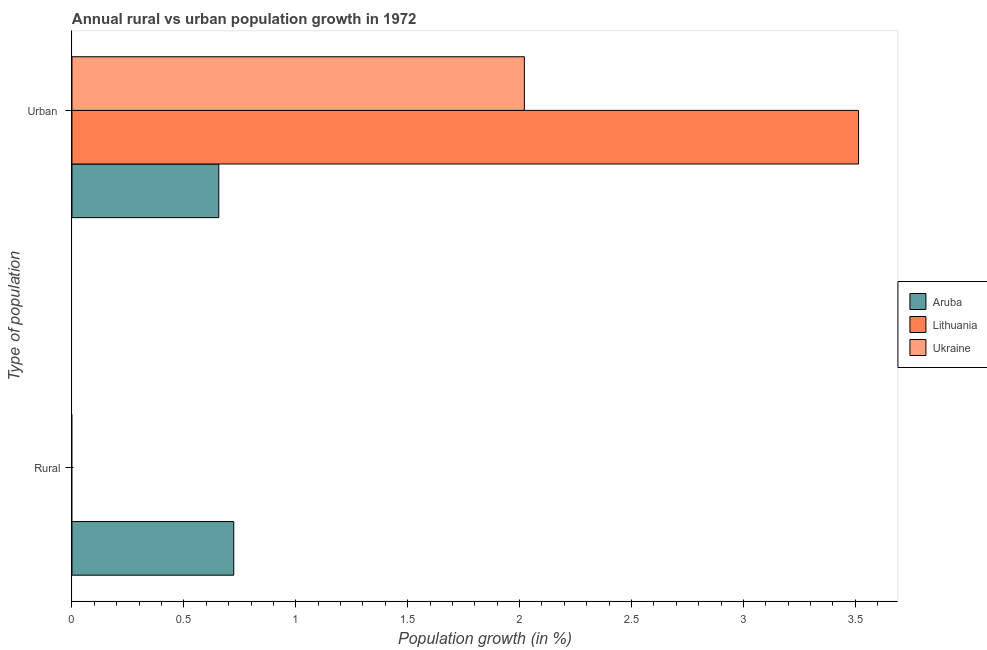Are the number of bars per tick equal to the number of legend labels?
Your response must be concise. No. Are the number of bars on each tick of the Y-axis equal?
Offer a terse response. No. How many bars are there on the 1st tick from the top?
Ensure brevity in your answer.  3. What is the label of the 2nd group of bars from the top?
Give a very brief answer. Rural. What is the urban population growth in Ukraine?
Provide a succinct answer. 2.02. Across all countries, what is the maximum urban population growth?
Ensure brevity in your answer.  3.51. Across all countries, what is the minimum urban population growth?
Offer a very short reply. 0.66. In which country was the urban population growth maximum?
Your answer should be compact. Lithuania. What is the total rural population growth in the graph?
Your answer should be compact. 0.72. What is the difference between the urban population growth in Lithuania and that in Ukraine?
Offer a terse response. 1.49. What is the difference between the urban population growth in Lithuania and the rural population growth in Ukraine?
Your response must be concise. 3.51. What is the average urban population growth per country?
Your response must be concise. 2.06. What is the difference between the rural population growth and urban population growth in Aruba?
Your response must be concise. 0.07. What is the ratio of the urban population growth in Aruba to that in Ukraine?
Give a very brief answer. 0.32. How many bars are there?
Keep it short and to the point. 4. How many countries are there in the graph?
Your answer should be compact. 3. What is the difference between two consecutive major ticks on the X-axis?
Offer a terse response. 0.5. Are the values on the major ticks of X-axis written in scientific E-notation?
Provide a short and direct response. No. Does the graph contain any zero values?
Your answer should be compact. Yes. How many legend labels are there?
Provide a succinct answer. 3. How are the legend labels stacked?
Give a very brief answer. Vertical. What is the title of the graph?
Your response must be concise. Annual rural vs urban population growth in 1972. What is the label or title of the X-axis?
Offer a very short reply. Population growth (in %). What is the label or title of the Y-axis?
Keep it short and to the point. Type of population. What is the Population growth (in %) in Aruba in Rural?
Offer a terse response. 0.72. What is the Population growth (in %) of Ukraine in Rural?
Give a very brief answer. 0. What is the Population growth (in %) in Aruba in Urban ?
Keep it short and to the point. 0.66. What is the Population growth (in %) in Lithuania in Urban ?
Your answer should be very brief. 3.51. What is the Population growth (in %) in Ukraine in Urban ?
Offer a terse response. 2.02. Across all Type of population, what is the maximum Population growth (in %) in Aruba?
Your answer should be very brief. 0.72. Across all Type of population, what is the maximum Population growth (in %) in Lithuania?
Offer a terse response. 3.51. Across all Type of population, what is the maximum Population growth (in %) of Ukraine?
Provide a short and direct response. 2.02. Across all Type of population, what is the minimum Population growth (in %) of Aruba?
Your answer should be compact. 0.66. Across all Type of population, what is the minimum Population growth (in %) of Lithuania?
Ensure brevity in your answer.  0. Across all Type of population, what is the minimum Population growth (in %) in Ukraine?
Provide a succinct answer. 0. What is the total Population growth (in %) in Aruba in the graph?
Provide a succinct answer. 1.38. What is the total Population growth (in %) of Lithuania in the graph?
Offer a terse response. 3.51. What is the total Population growth (in %) in Ukraine in the graph?
Your answer should be very brief. 2.02. What is the difference between the Population growth (in %) of Aruba in Rural and that in Urban ?
Make the answer very short. 0.07. What is the difference between the Population growth (in %) in Aruba in Rural and the Population growth (in %) in Lithuania in Urban ?
Keep it short and to the point. -2.79. What is the difference between the Population growth (in %) of Aruba in Rural and the Population growth (in %) of Ukraine in Urban ?
Your response must be concise. -1.3. What is the average Population growth (in %) in Aruba per Type of population?
Make the answer very short. 0.69. What is the average Population growth (in %) of Lithuania per Type of population?
Offer a very short reply. 1.76. What is the average Population growth (in %) in Ukraine per Type of population?
Give a very brief answer. 1.01. What is the difference between the Population growth (in %) of Aruba and Population growth (in %) of Lithuania in Urban ?
Ensure brevity in your answer.  -2.86. What is the difference between the Population growth (in %) in Aruba and Population growth (in %) in Ukraine in Urban ?
Ensure brevity in your answer.  -1.37. What is the difference between the Population growth (in %) of Lithuania and Population growth (in %) of Ukraine in Urban ?
Offer a terse response. 1.49. What is the ratio of the Population growth (in %) in Aruba in Rural to that in Urban ?
Your answer should be compact. 1.1. What is the difference between the highest and the second highest Population growth (in %) in Aruba?
Make the answer very short. 0.07. What is the difference between the highest and the lowest Population growth (in %) of Aruba?
Keep it short and to the point. 0.07. What is the difference between the highest and the lowest Population growth (in %) in Lithuania?
Keep it short and to the point. 3.51. What is the difference between the highest and the lowest Population growth (in %) of Ukraine?
Offer a terse response. 2.02. 